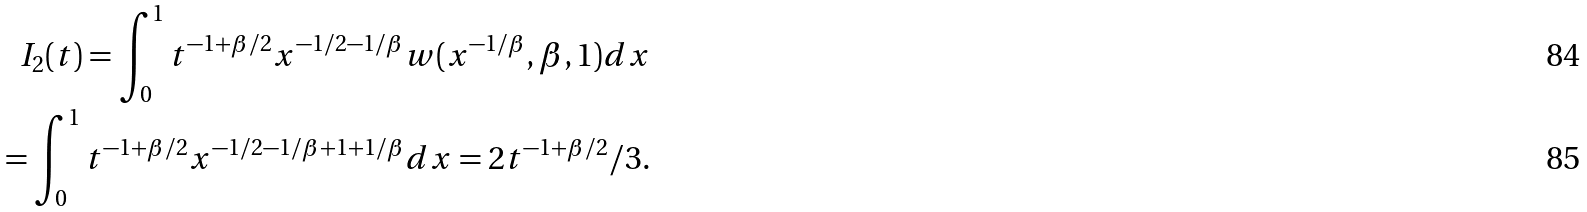<formula> <loc_0><loc_0><loc_500><loc_500>I _ { 2 } ( t ) = \int _ { 0 } ^ { 1 } t ^ { - 1 + \beta / 2 } x ^ { - 1 / 2 - 1 / \beta } w ( x ^ { - 1 / \beta } , \beta , 1 ) d x \\ = \int _ { 0 } ^ { 1 } t ^ { - 1 + \beta / 2 } x ^ { - 1 / 2 - 1 / \beta + 1 + 1 / \beta } d x = 2 t ^ { - 1 + \beta / 2 } / 3 .</formula> 